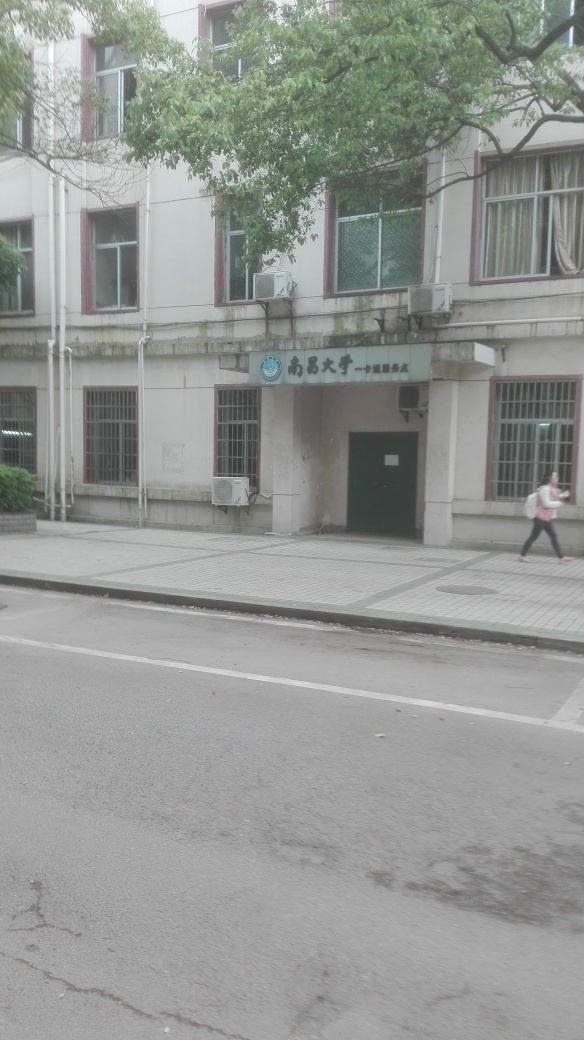Is the background clear and detailed? The background in the image has elements that are distinguishable, such as trees, a building facade with windows, and an air conditioning unit. However, the details are not crisp due to the quality of the image, and certain areas appear overexposed, affecting the clarity. 